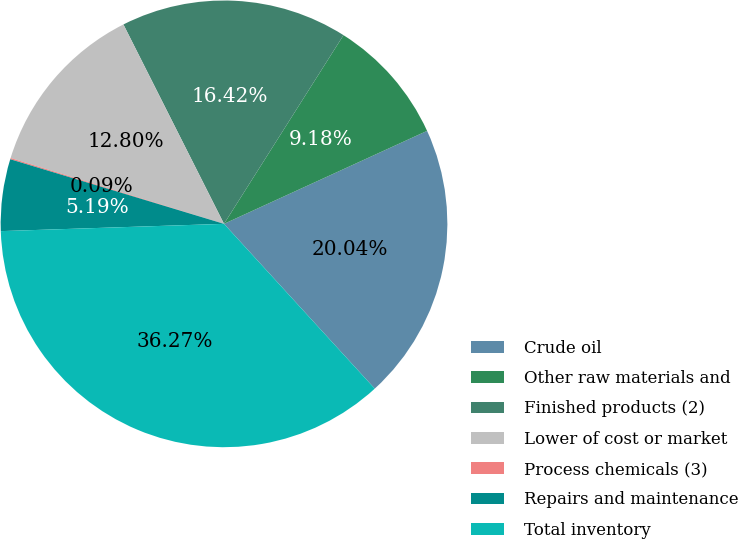<chart> <loc_0><loc_0><loc_500><loc_500><pie_chart><fcel>Crude oil<fcel>Other raw materials and<fcel>Finished products (2)<fcel>Lower of cost or market<fcel>Process chemicals (3)<fcel>Repairs and maintenance<fcel>Total inventory<nl><fcel>20.04%<fcel>9.18%<fcel>16.42%<fcel>12.8%<fcel>0.09%<fcel>5.19%<fcel>36.27%<nl></chart> 